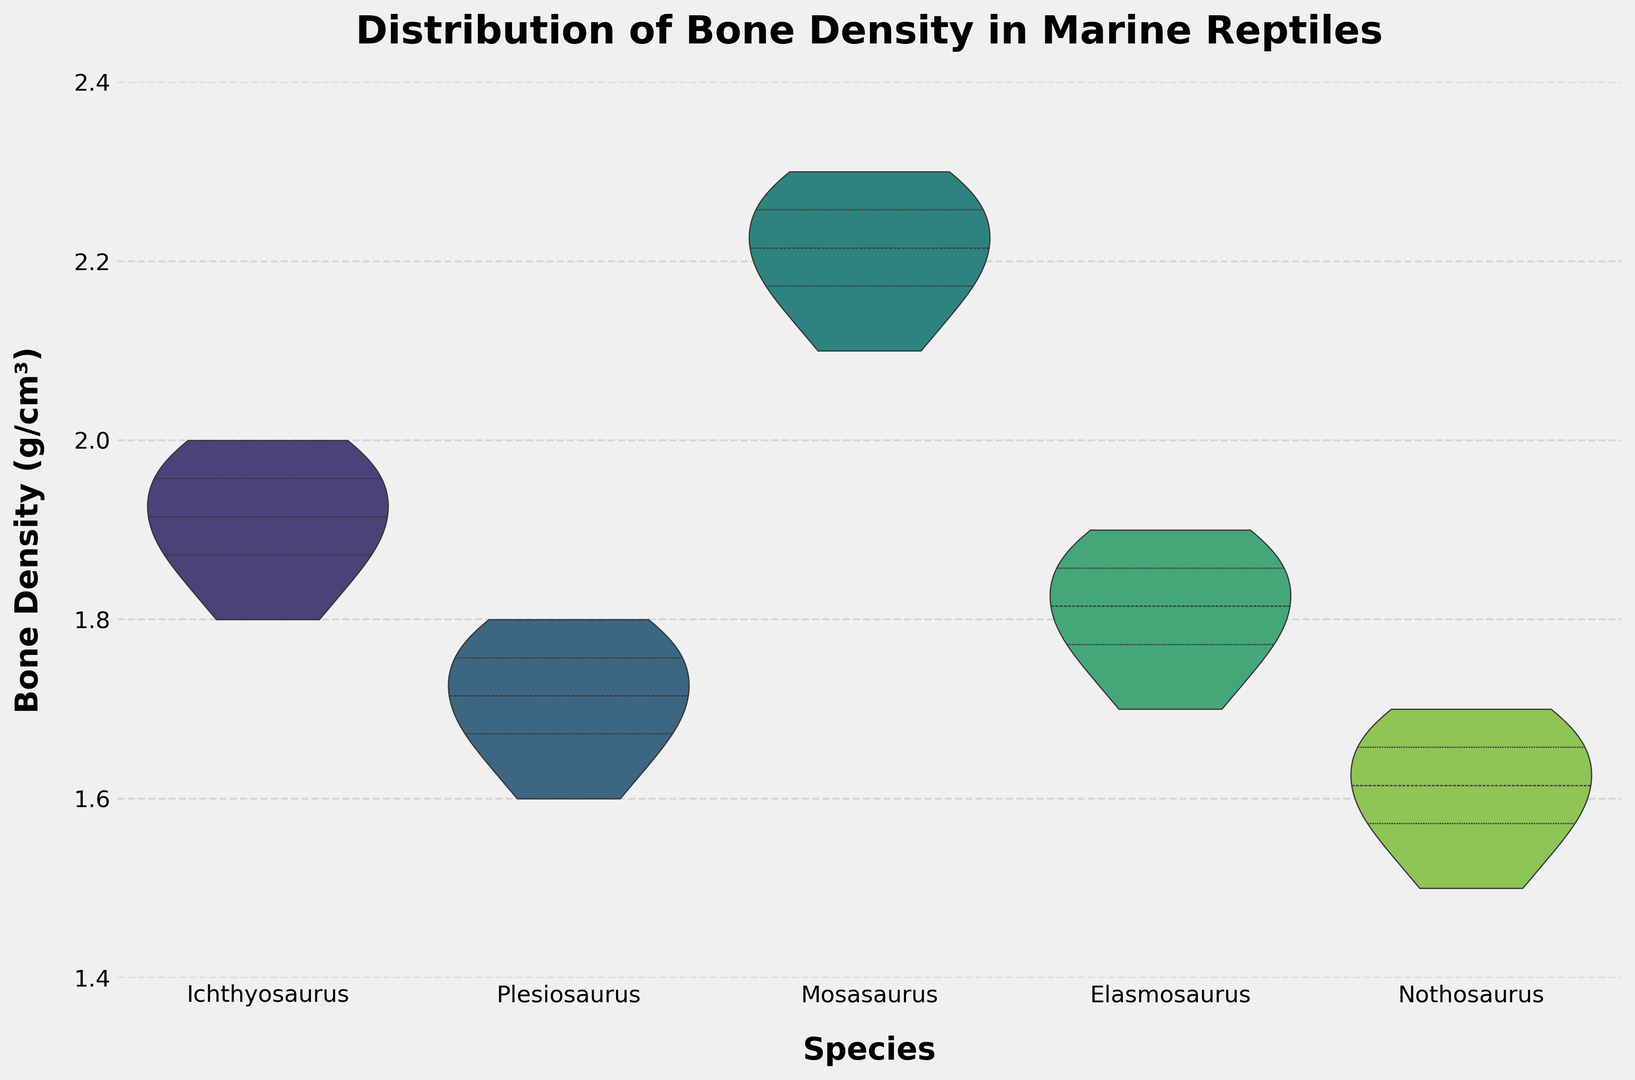What is the median bone density of Mosasaurus? To find the median bone density, observe the violin plot for Mosasaurus and identify the median line marked inside the violin shape.
Answer: 2.2 g/cm³ Which species has the widest distribution of bone density values? By comparing the widths of the violins for each species, the species with the widest distribution is the one with the violin plot covering the most extensive range along the y-axis.
Answer: Ichthyosaurus Which species has the highest quartile range in bone density? Look at the interquartile ranges (the width of the box lines inside the violins) and identify which has the largest distance from the first to the third quartile.
Answer: Mosasaurus What is the range (difference between maximum and minimum) of bone density values for Nothosaurus? Examine the Nothosaurus violin and note the highest and lowest points to find the range. The difference between 1.7 g/cm³ (max) and 1.5 g/cm³ (min) is 0.2 g/cm³.
Answer: 0.2 g/cm³ Which species shows the narrowest distribution of bone density values? The violin with the narrowest width represents the species with the least variation in bone density.
Answer: Nothosaurus What bone density value appears at the lower quartile for Plesiosaurus? Identify the lower quartile line within the Plesiosaurus violin plot, which typically represents the 25th percentile.
Answer: 1.68 g/cm³ How does the bone density distribution of Elasmosaurus compare to that of Plesiosaurus? Compare the shape and spread of the violins for Elasmosaurus and Plesiosaurus. You should note that Elasmosaurus has a slightly wider range and its densities appear higher overall.
Answer: Elasmosaurus has a slightly wider range and higher densities Does any species have bone densities that overlap with Nothosaurus? If so, which ones? Observe if the density range of Nothosaurus overlaps with the ranges of other species. Notably, the density ranges overlap with Plesiosaurus and Elasmosaurus within some part of the range.
Answer: Plesiosaurus, Elasmosaurus Are there any species that show a bimodal distribution in bone density? Look for violins with two peaks or modes within the density distributions, indicating bimodality.
Answer: No species shows a bimodal distribution 